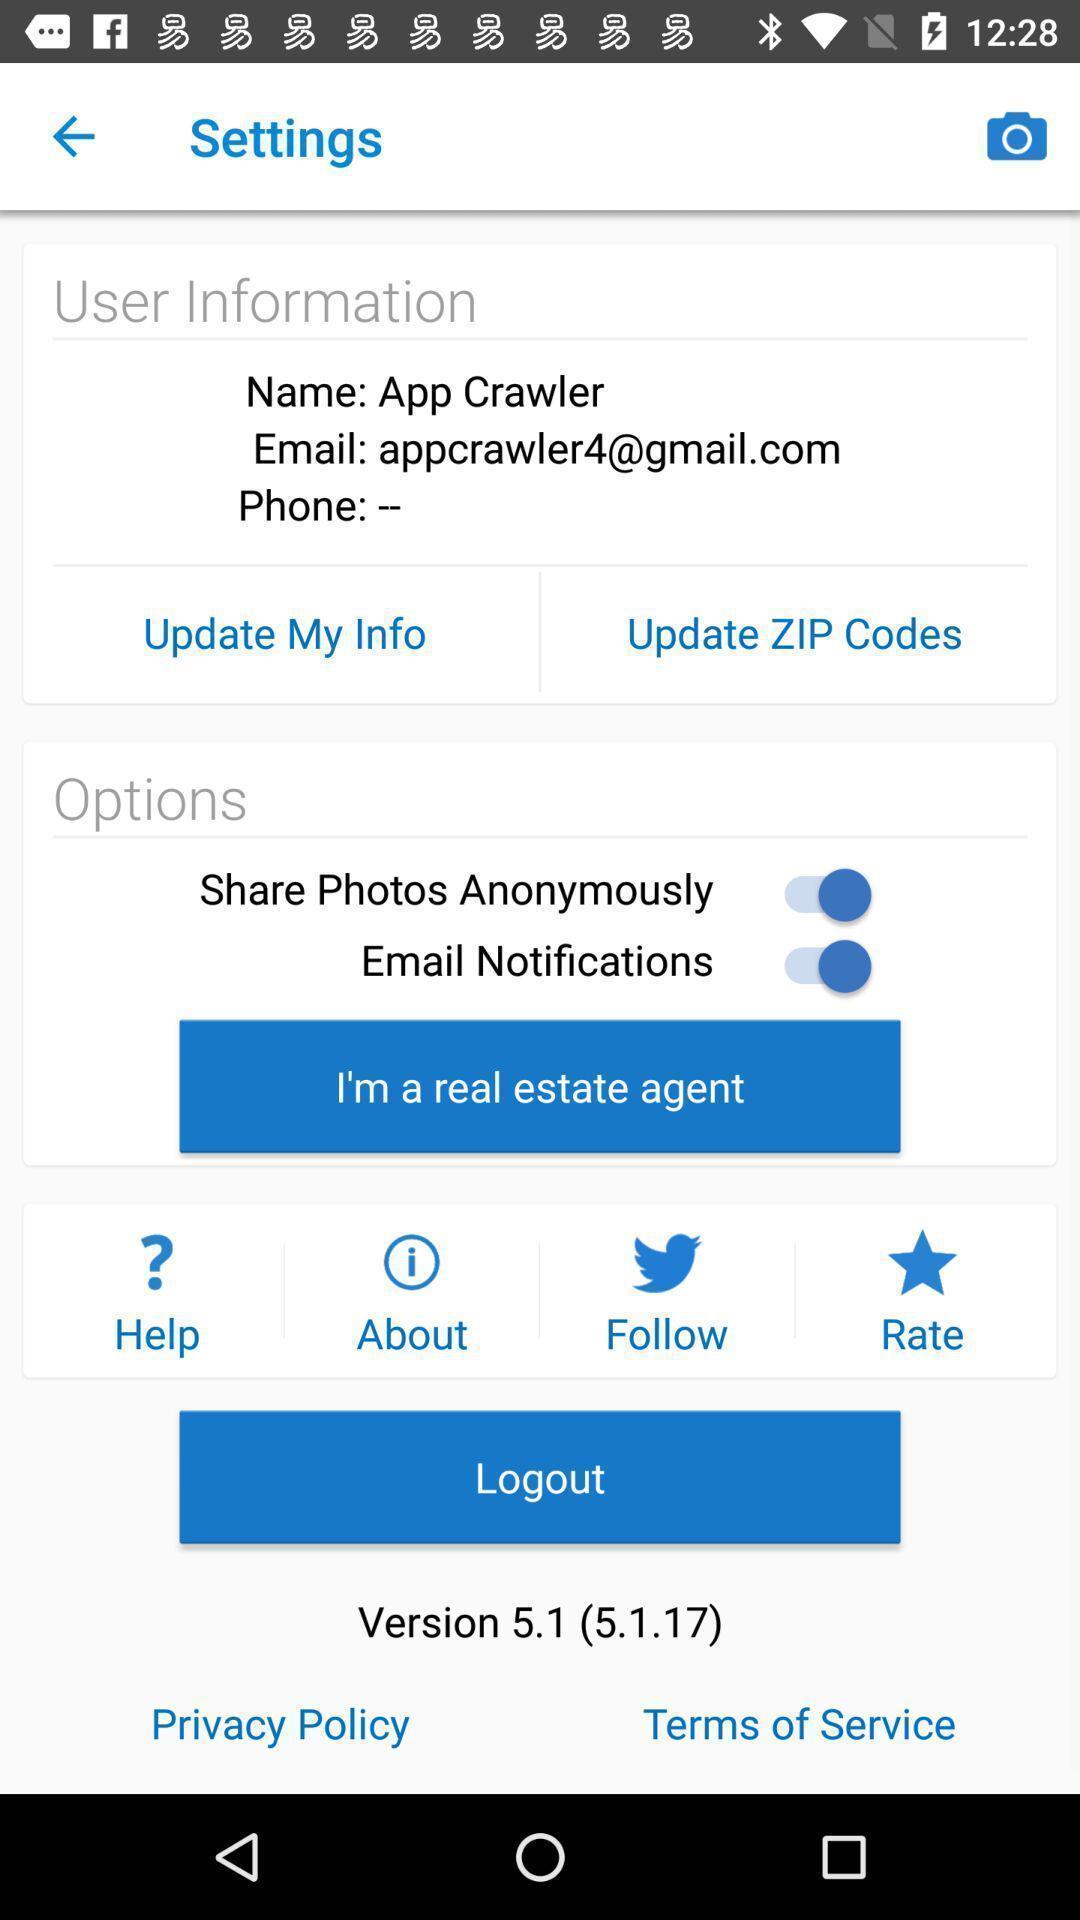Describe the key features of this screenshot. Settings page showing app details and different enabling options. 